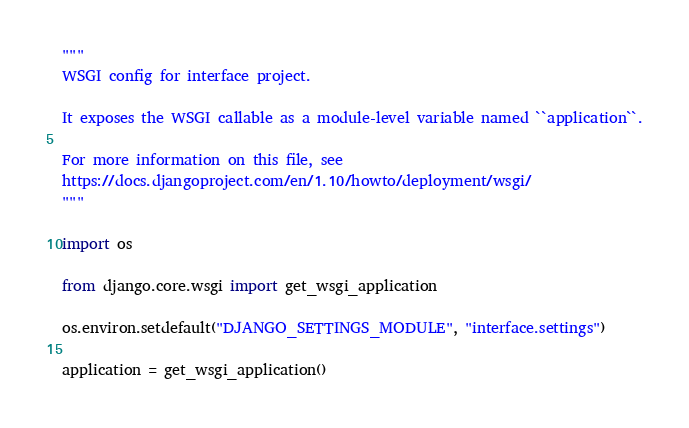Convert code to text. <code><loc_0><loc_0><loc_500><loc_500><_Python_>"""
WSGI config for interface project.

It exposes the WSGI callable as a module-level variable named ``application``.

For more information on this file, see
https://docs.djangoproject.com/en/1.10/howto/deployment/wsgi/
"""

import os

from django.core.wsgi import get_wsgi_application

os.environ.setdefault("DJANGO_SETTINGS_MODULE", "interface.settings")

application = get_wsgi_application()
</code> 